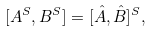Convert formula to latex. <formula><loc_0><loc_0><loc_500><loc_500>[ A ^ { S } , B ^ { S } ] = [ \hat { A } , \hat { B } ] ^ { S } ,</formula> 